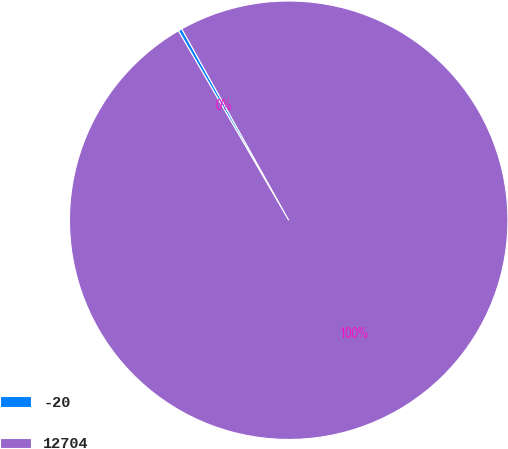Convert chart to OTSL. <chart><loc_0><loc_0><loc_500><loc_500><pie_chart><fcel>-20<fcel>12704<nl><fcel>0.28%<fcel>99.72%<nl></chart> 